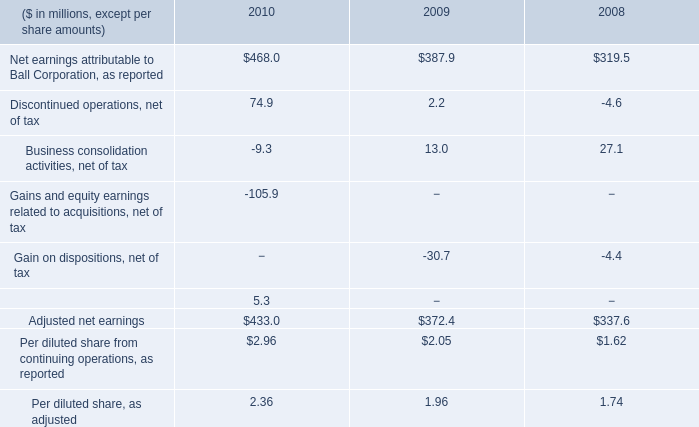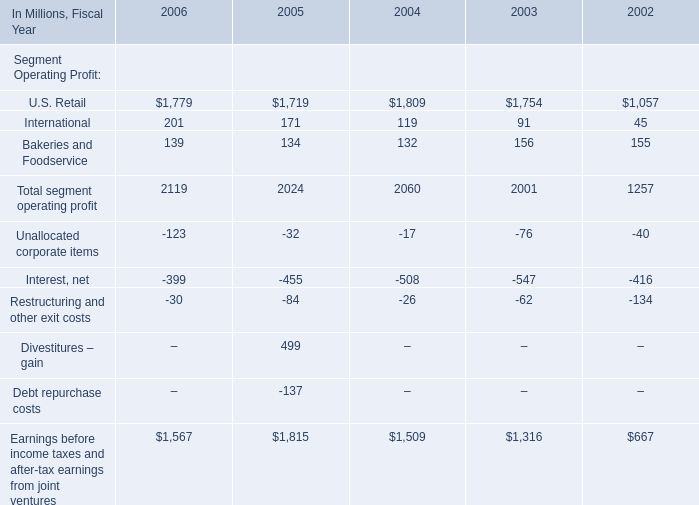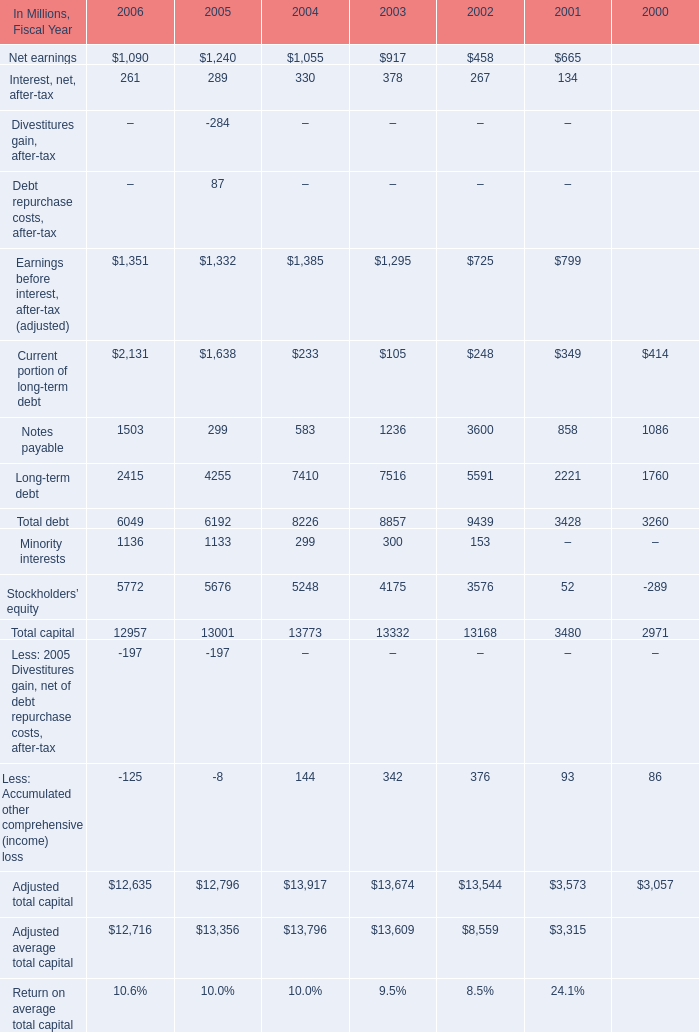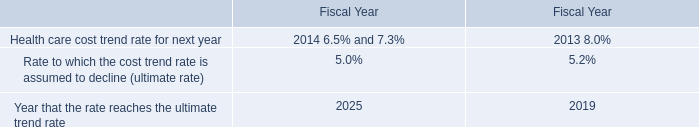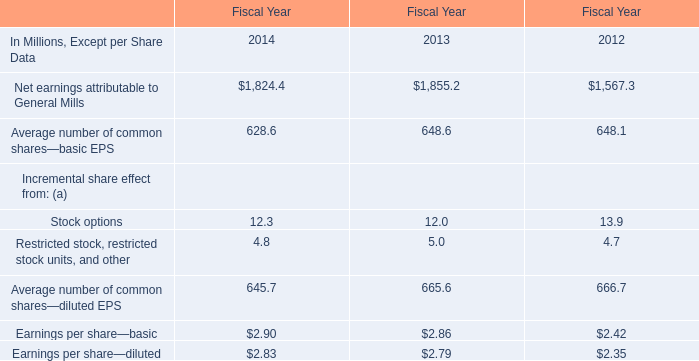Which Fiscal Year is Total segment operating profit between 2030 Million and 2070 Million? 
Answer: 2004. 